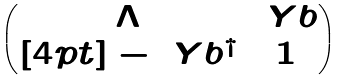<formula> <loc_0><loc_0><loc_500><loc_500>\begin{pmatrix} \Lambda & \ Y b \\ [ 4 p t ] - \ Y b ^ { \dag } & 1 \end{pmatrix}</formula> 